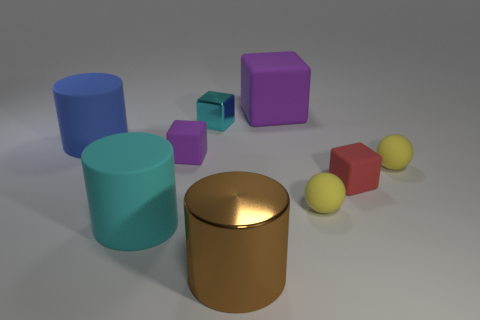Add 1 tiny yellow shiny cylinders. How many objects exist? 10 Subtract all cyan cylinders. How many cylinders are left? 2 Subtract all cyan cylinders. How many cylinders are left? 2 Subtract all cylinders. How many objects are left? 6 Subtract all red cylinders. How many gray cubes are left? 0 Subtract 0 cyan balls. How many objects are left? 9 Subtract 1 balls. How many balls are left? 1 Subtract all green blocks. Subtract all yellow spheres. How many blocks are left? 4 Subtract all tiny green shiny cylinders. Subtract all large rubber cubes. How many objects are left? 8 Add 9 red objects. How many red objects are left? 10 